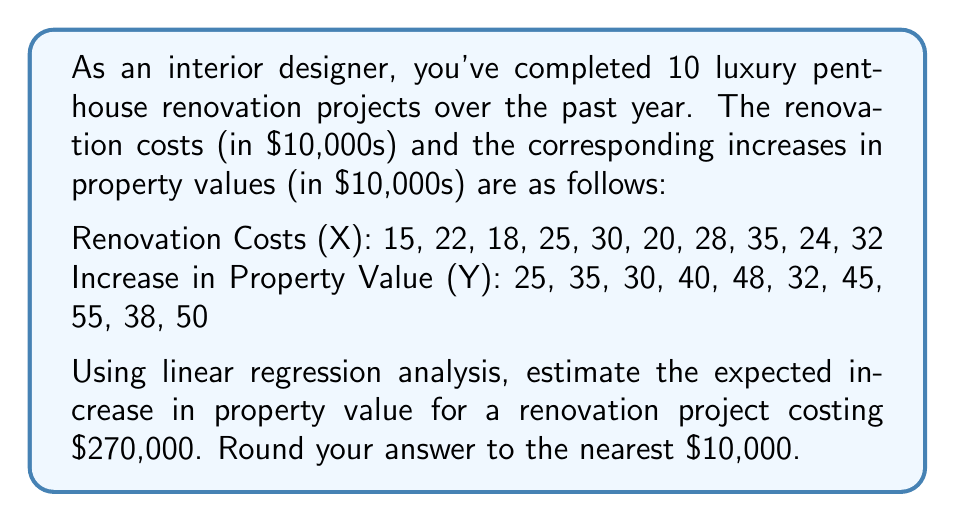Give your solution to this math problem. To solve this problem, we'll use simple linear regression analysis. Let's follow these steps:

1. Calculate the means of X and Y:
   $\bar{X} = \frac{15 + 22 + 18 + 25 + 30 + 20 + 28 + 35 + 24 + 32}{10} = 24.9$
   $\bar{Y} = \frac{25 + 35 + 30 + 40 + 48 + 32 + 45 + 55 + 38 + 50}{10} = 39.8$

2. Calculate the slope (b) of the regression line:
   $$b = \frac{\sum(X_i - \bar{X})(Y_i - \bar{Y})}{\sum(X_i - \bar{X})^2}$$

3. Calculate the y-intercept (a):
   $$a = \bar{Y} - b\bar{X}$$

4. Using a calculator or spreadsheet for these calculations, we get:
   $b \approx 1.5789$
   $a \approx 0.4737$

5. The regression equation is:
   $$Y = 0.4737 + 1.5789X$$

6. For a renovation cost of $270,000, X = 27 (in $10,000s)
   
   Plugging this into our equation:
   $$Y = 0.4737 + 1.5789(27) \approx 43.1040$$

7. Converting back to dollars and rounding to the nearest $10,000:
   $43.1040 * $10,000 ≈ $431,040 ≈ $430,000$
Answer: $430,000 